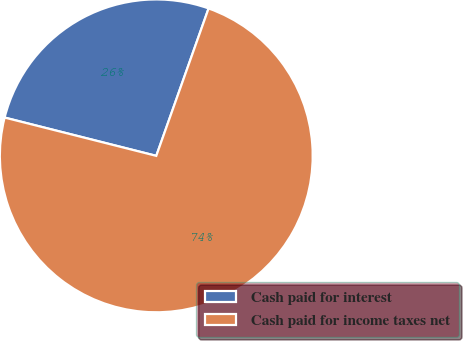Convert chart. <chart><loc_0><loc_0><loc_500><loc_500><pie_chart><fcel>Cash paid for interest<fcel>Cash paid for income taxes net<nl><fcel>26.49%<fcel>73.51%<nl></chart> 